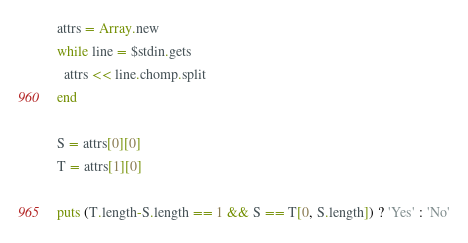Convert code to text. <code><loc_0><loc_0><loc_500><loc_500><_Ruby_>attrs = Array.new
while line = $stdin.gets
  attrs << line.chomp.split
end

S = attrs[0][0]
T = attrs[1][0]

puts (T.length-S.length == 1 && S == T[0, S.length]) ? 'Yes' : 'No'</code> 